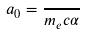<formula> <loc_0><loc_0><loc_500><loc_500>a _ { 0 } = \frac { } { m _ { e } c \alpha }</formula> 